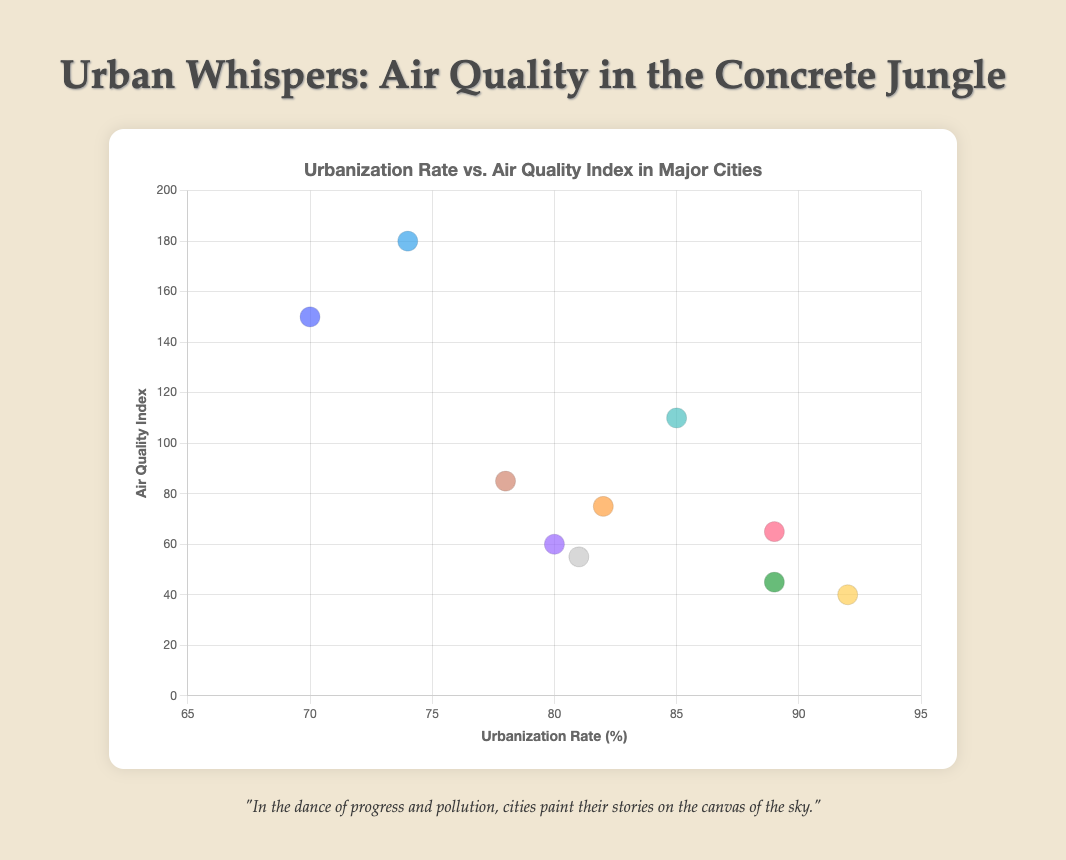what is the title of the figure? The title can be found at the top center of the figure, indicating the overall theme or subject.
Answer: Urban Whispers: Air Quality in the Concrete Jungle what are the x-axis and y-axis labels? Both axis labels can be identified by looking horizontally or vertically next to the axes. The x-axis label is placed along the horizontal axis, and the y-axis label is placed alongside the vertical axis.
Answer: Urbanization Rate (%) and Air Quality Index which city has the highest urbanization rate and what is its air quality index? Look for the data point with the highest x-coordinate value which represents the highest urbanization rate. The corresponding y-coordinate gives the air quality index.
Answer: Tokyo, 40 what is the overall trend in air quality index as urbanization rate increases? Visually inspect the plot to observe any patterns or relationships between urbanization rate (x-axis) and air quality index (y-axis).
Answer: There is no clear overall trend which city has the lowest air quality index and what is its urbanization rate? Find the data point with the lowest y-coordinate value, representing the lowest air quality index. The corresponding x-coordinate gives the urbanization rate.
Answer: Tokyo, 92% how many cities have an air quality index greater than 100? Count all the data points where the y-coordinate (air quality index) is greater than 100.
Answer: 3 what is the difference in urbanization rates between the cities with the highest and lowest air quality index? Identify the urbanization rate values of the cities with the highest and lowest air quality index, then subtract the smaller value from the larger one.
Answer: 92 - 40 = 52 which cities have a similar urbanization rate? Examine data points that cluster around the same x-coordinate values. Identify if there are cities that have urbanization rates close to each other.
Answer: Los Angeles and Sydney; London and Paris is there a city with both high urbanization rate and high air quality index? Check for a data point that has high values on both the x and y axes. Typically, high values on the x-axis (urbanization rate) and low values on the y-axis (air quality index) need to be determined visually.
Answer: Yes, Tokyo which city has the closest combination of urbanization rate and air quality index to Mexico City? Compare the coordinates of other cities to Mexico City’s coordinates: 78 for urbanization rate and 85 for air quality index. Find the closest point visually.
Answer: São Paulo 